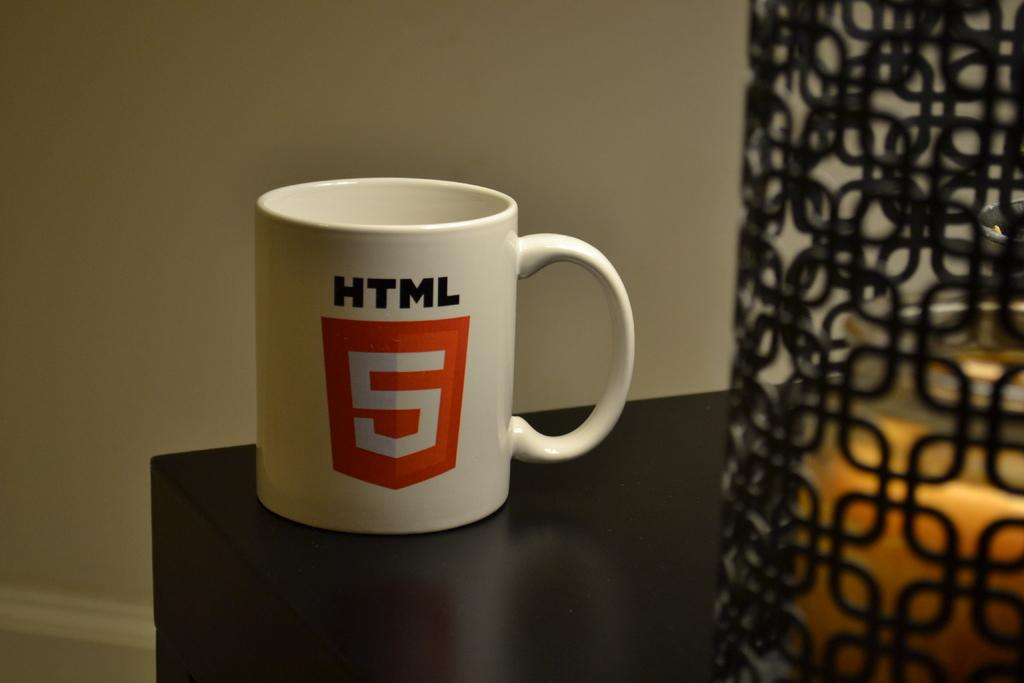<image>
Share a concise interpretation of the image provided. White HTLM 5 coffee mug on top of a brown table. 